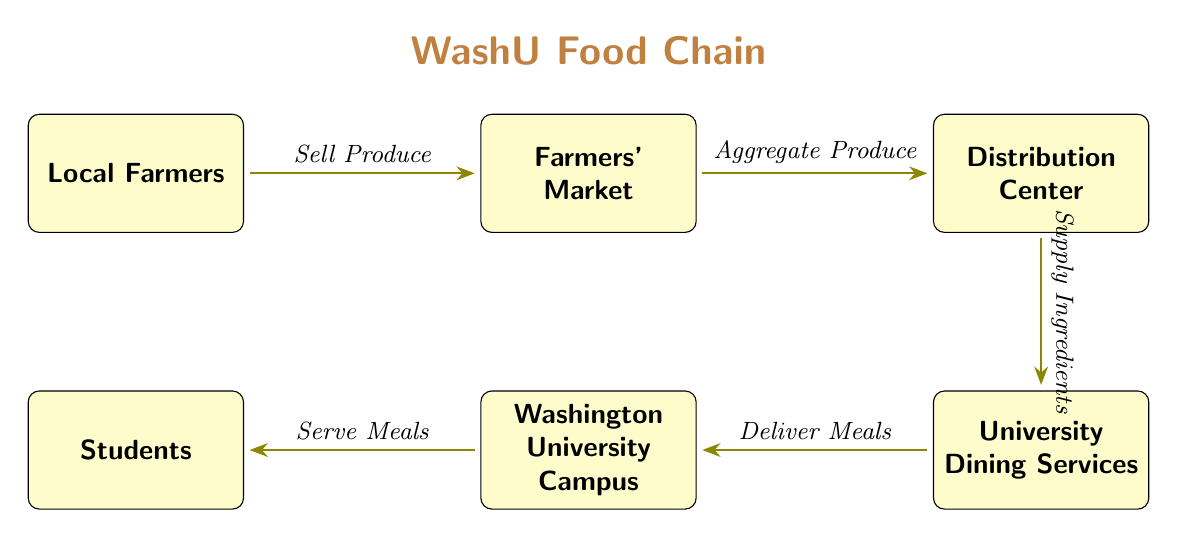What is the starting node of the food chain? The diagram shows that the food chain begins with the "Local Farmers" node. This node is positioned at the leftmost side of the diagram, indicating it as the starting point from which the chain flows.
Answer: Local Farmers How many nodes are present in the food chain? By counting each distinct box in the diagram, we find there are six nodes: Local Farmers, Farmers' Market, Distribution Center, University Dining Services, Washington University Campus, and Students.
Answer: 6 What is the relationship between the Farmers' Market and the Distribution Center? The diagram indicates that the Farmers' Market sends its produce to the Distribution Center, as represented by the arrow labeled "Aggregate Produce." This describes the flow of produce from the market to the distribution point.
Answer: Aggregate Produce Who receives the meals after they are delivered? According to the diagram, the arrow labeled "Serve Meals" shows that the students on the Washington University Campus are the ones who receive the meals delivered from University Dining Services.
Answer: Students What does the University Dining Services do with the produce? The diagram clearly shows that University Dining Services receives ingredients from the Distribution Center, as indicated by the arrow labeled "Supply Ingredients," which directly links these two nodes.
Answer: Supply Ingredients Which node is immediately before the Students node in the food chain? The diagram shows that the node immediately before Students is the Washington University Campus. This is determined by tracing the path backwards from the Students node to see which node precedes it.
Answer: Washington University Campus What action occurs between the Local Farmers and the Farmers' Market? The diagram specifies an interaction where the Local Farmers "Sell Produce" to the Farmers' Market. This relationship is visually represented by the directed arrow from the Local Farmers to the Farmers' Market.
Answer: Sell Produce Which node has a direct outgoing connection to the Washington University Campus? The University Dining Services node is shown to have a direct outgoing connection to the Washington University Campus through the arrow labeled "Deliver Meals." This indicates that meals are delivered straight from dining services to the campus.
Answer: University Dining Services What is the final step of the food chain? The last step in the food chain is indicated by the connection from the Washington University Campus to the Students, labeled "Serve Meals." This denotes that the final action is serving meals to the students on campus.
Answer: Serve Meals 